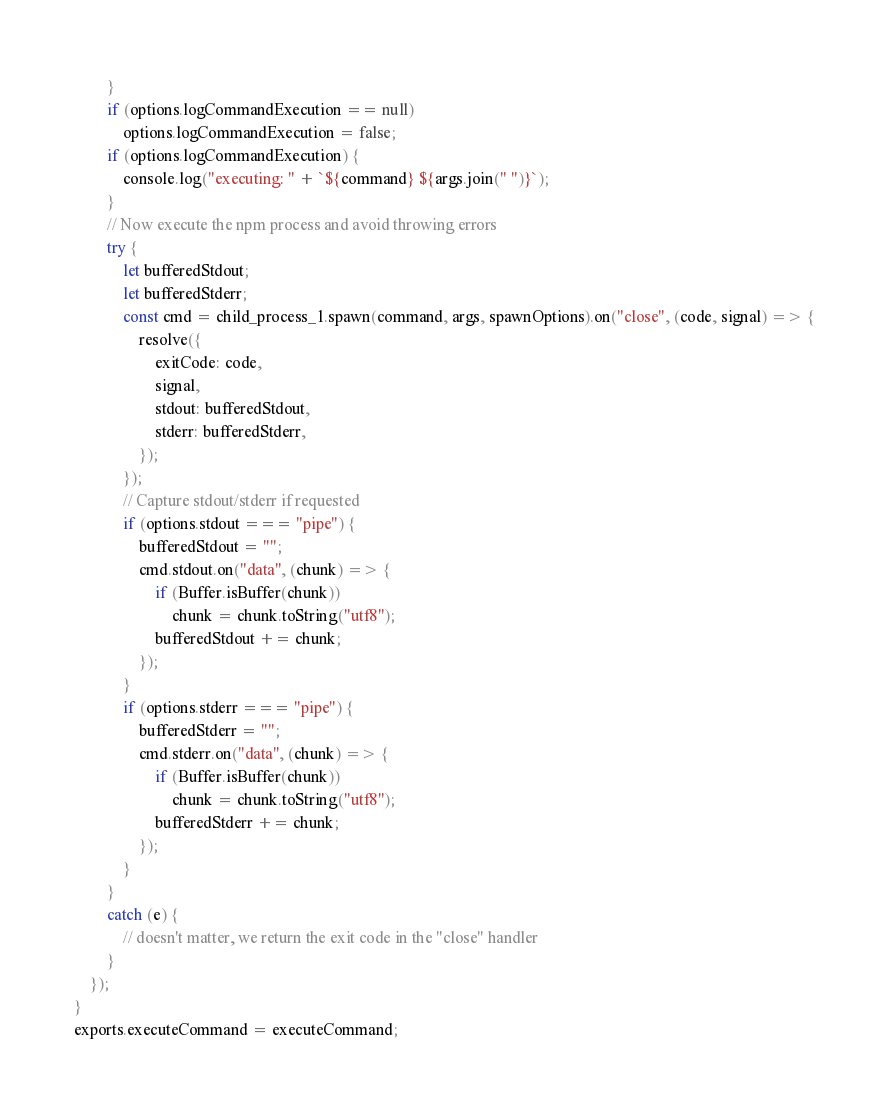Convert code to text. <code><loc_0><loc_0><loc_500><loc_500><_JavaScript_>        }
        if (options.logCommandExecution == null)
            options.logCommandExecution = false;
        if (options.logCommandExecution) {
            console.log("executing: " + `${command} ${args.join(" ")}`);
        }
        // Now execute the npm process and avoid throwing errors
        try {
            let bufferedStdout;
            let bufferedStderr;
            const cmd = child_process_1.spawn(command, args, spawnOptions).on("close", (code, signal) => {
                resolve({
                    exitCode: code,
                    signal,
                    stdout: bufferedStdout,
                    stderr: bufferedStderr,
                });
            });
            // Capture stdout/stderr if requested
            if (options.stdout === "pipe") {
                bufferedStdout = "";
                cmd.stdout.on("data", (chunk) => {
                    if (Buffer.isBuffer(chunk))
                        chunk = chunk.toString("utf8");
                    bufferedStdout += chunk;
                });
            }
            if (options.stderr === "pipe") {
                bufferedStderr = "";
                cmd.stderr.on("data", (chunk) => {
                    if (Buffer.isBuffer(chunk))
                        chunk = chunk.toString("utf8");
                    bufferedStderr += chunk;
                });
            }
        }
        catch (e) {
            // doesn't matter, we return the exit code in the "close" handler
        }
    });
}
exports.executeCommand = executeCommand;
</code> 